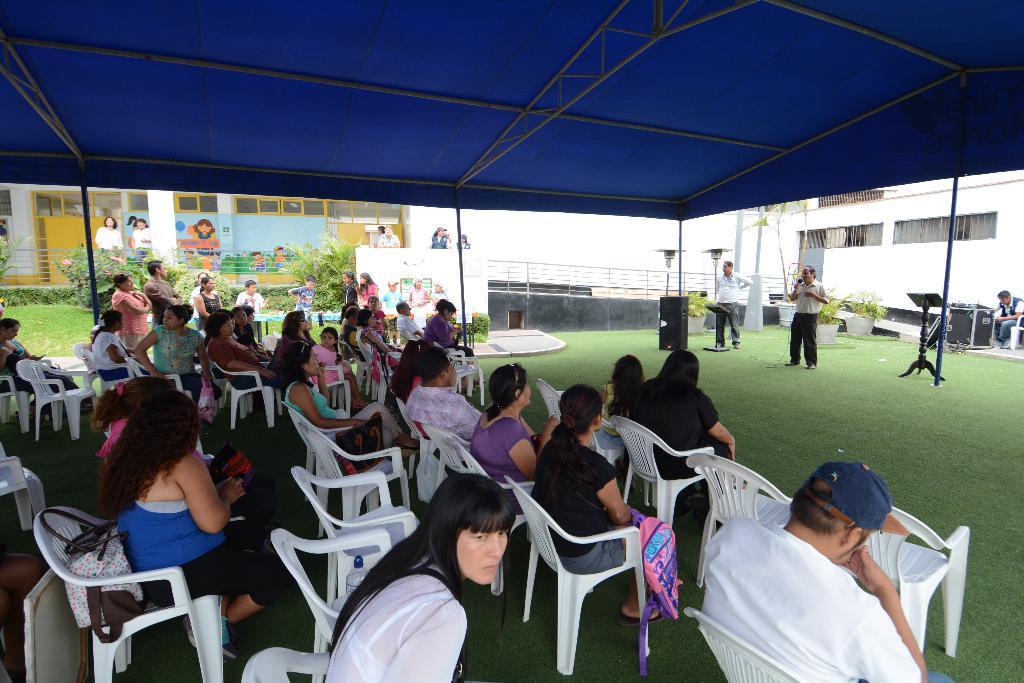Please provide a concise description of this image. There are few people here sitting on the chair and few people standing here and here this person is holding microphone and speaking something,next to him we see a speaker. And they are under a tent. And we can see in the background a building. 